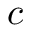<formula> <loc_0><loc_0><loc_500><loc_500>c</formula> 